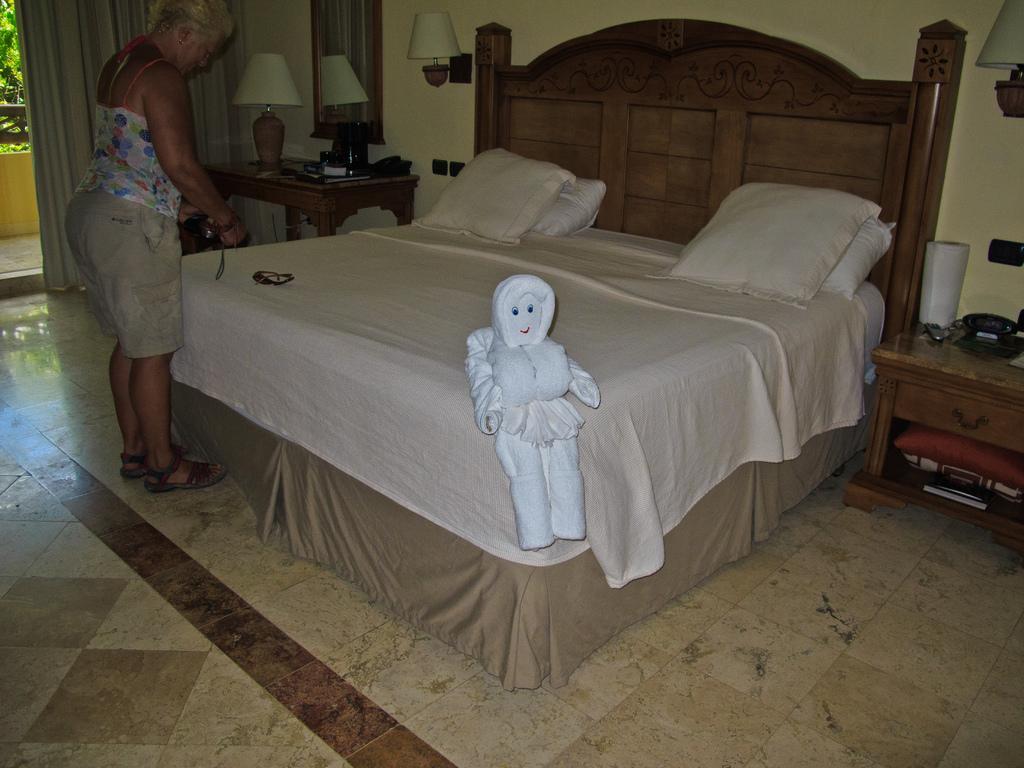In one or two sentences, can you explain what this image depicts? This picture is clicked inside a bedroom. There is a big bed at the center of the room. On the bed there are pillows, a toy and sunglasses. Near to the bed there is a woman standing. On the either sides of the bed there are tables. The table at the right corner there is a mobile phone, a paper roll, a book and a pillow. On the table at the left corner there is a table lamp, books and some things. Above to it there is a mirror on the wall. On the above left corner of the image there is a curtain, railing and trees. In the background there is wall and wall lamps hanging to it. 